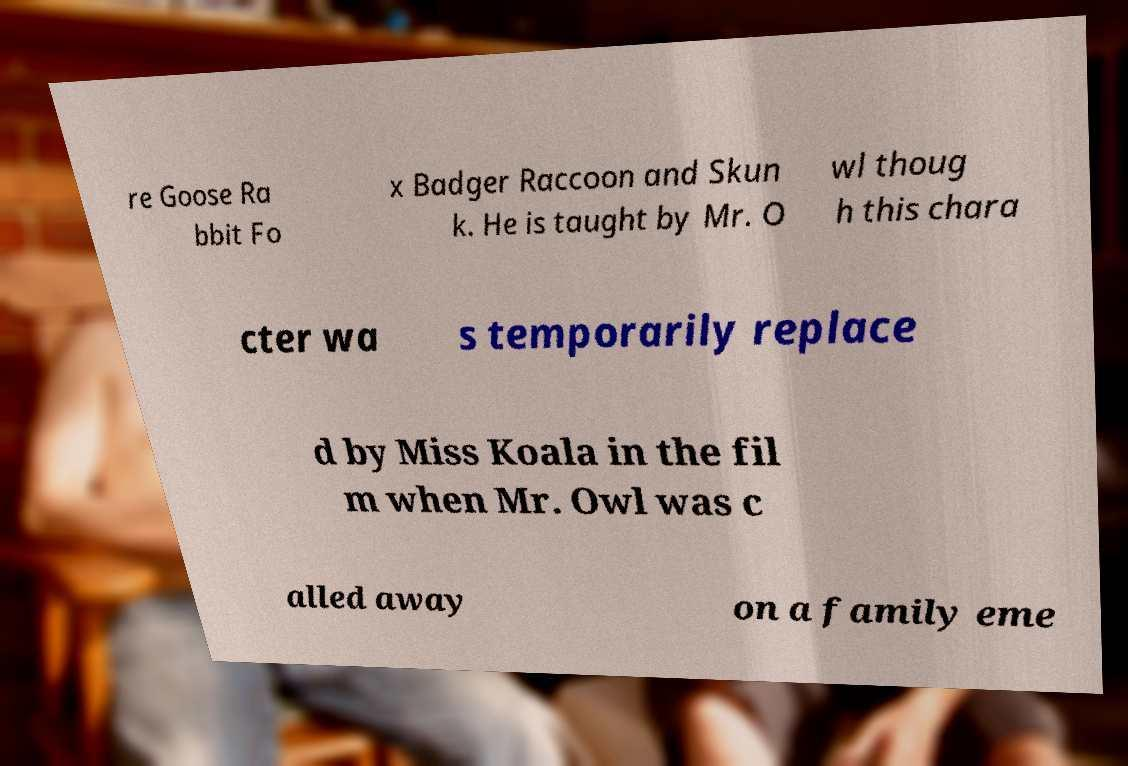Can you accurately transcribe the text from the provided image for me? re Goose Ra bbit Fo x Badger Raccoon and Skun k. He is taught by Mr. O wl thoug h this chara cter wa s temporarily replace d by Miss Koala in the fil m when Mr. Owl was c alled away on a family eme 